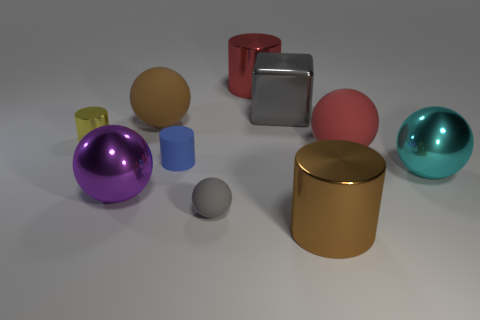Subtract all blue rubber cylinders. How many cylinders are left? 3 Subtract all brown cylinders. How many cylinders are left? 3 Subtract all cylinders. How many objects are left? 6 Subtract all gray cylinders. How many yellow cubes are left? 0 Subtract 1 purple balls. How many objects are left? 9 Subtract 4 balls. How many balls are left? 1 Subtract all purple balls. Subtract all purple cubes. How many balls are left? 4 Subtract all tiny yellow things. Subtract all balls. How many objects are left? 4 Add 4 cubes. How many cubes are left? 5 Add 6 small yellow cylinders. How many small yellow cylinders exist? 7 